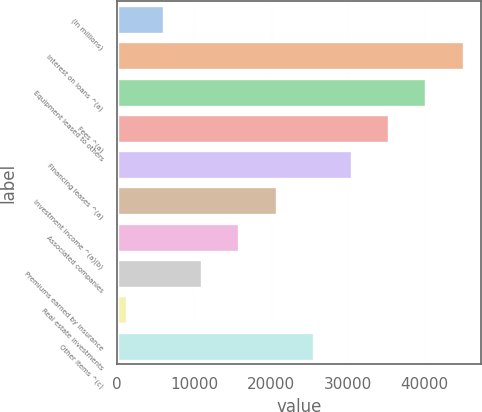<chart> <loc_0><loc_0><loc_500><loc_500><bar_chart><fcel>(In millions)<fcel>Interest on loans ^(a)<fcel>Equipment leased to others<fcel>Fees ^(a)<fcel>Financing leases ^(a)<fcel>Investment income ^(a)(b)<fcel>Associated companies<fcel>Premiums earned by insurance<fcel>Real estate investments<fcel>Other items ^(c)<nl><fcel>6112.6<fcel>45093.4<fcel>40220.8<fcel>35348.2<fcel>30475.6<fcel>20730.4<fcel>15857.8<fcel>10985.2<fcel>1240<fcel>25603<nl></chart> 